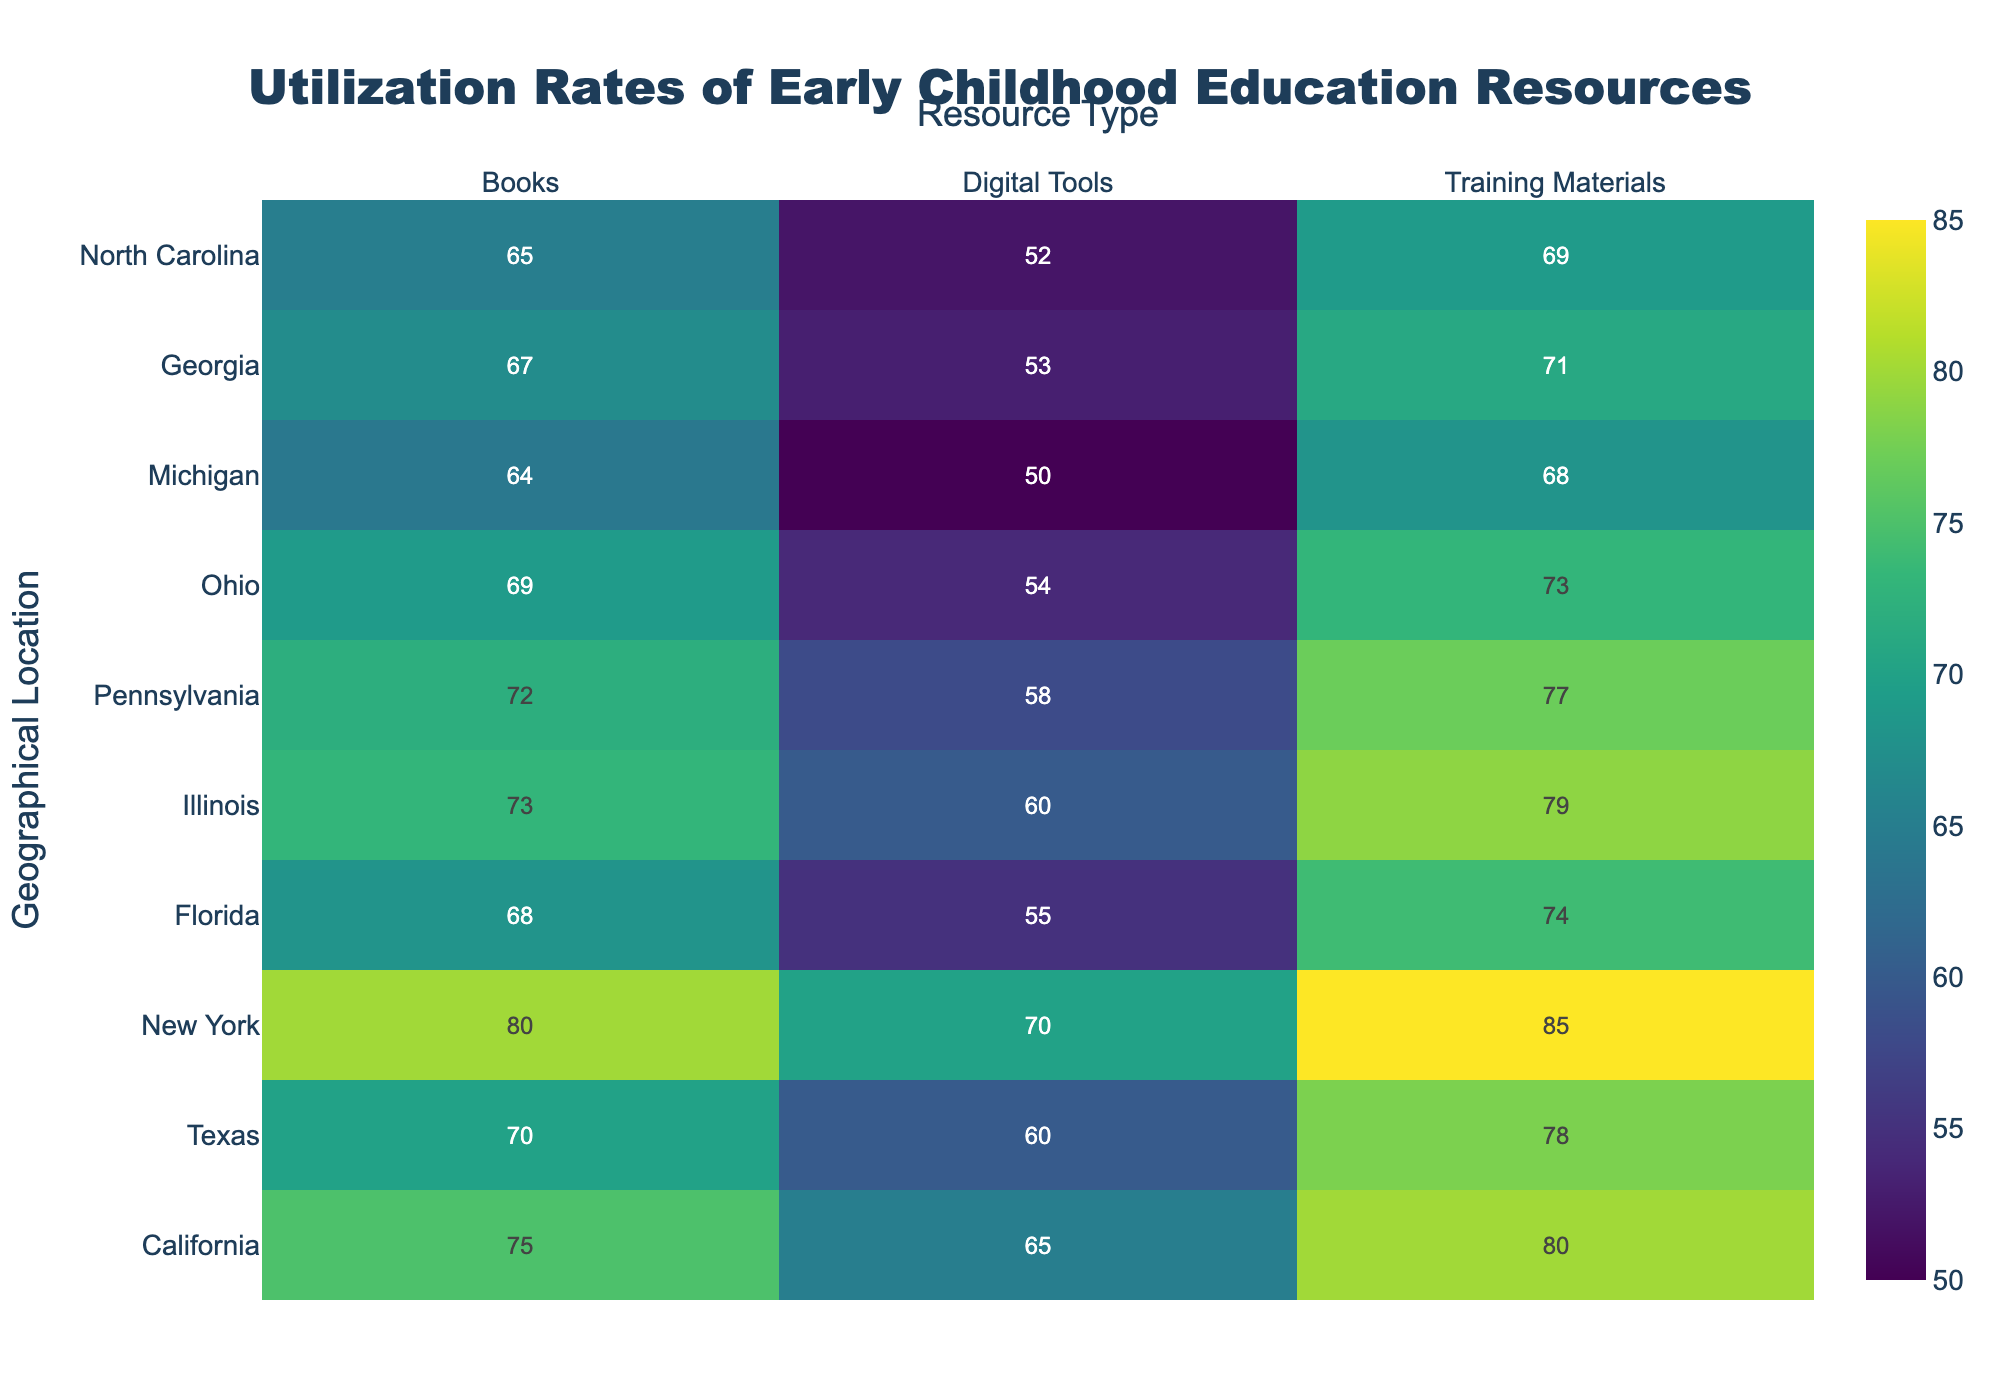What is the title of the heatmap? The title is positioned at the top of the figure. It summarizes the content of the heatmap.
Answer: Utilization Rates of Early Childhood Education Resources Which geographical location has the highest utilization rate for training materials? Look at the column for training materials and identify the highest value. The corresponding geographical location is the answer.
Answer: New York What is the average utilization rate of digital tools across all geographical locations? Add up the utilization rates for digital tools for all locations and then divide by the number of locations (10).
Answer: 57.7 Which resource type shows the highest utilization rate in Texas? Examine the row for Texas, compare the utilization rates for books, digital tools, and training materials. The highest value corresponds to the resource type.
Answer: Training Materials What is the difference in utilization rates for books between New York and Michigan? Subtract the utilization rate of books in Michigan from the utilization rate of books in New York.
Answer: 16 How does the utilization rate for digital tools in California compare to the rate in Florida? Compare the two values directly from the heatmap.
Answer: Higher in California Which geographic location has the lowest utilization rate for digital tools? Find the smallest value in the digital tools column and note the corresponding location.
Answer: Michigan What is the median utilization rate of training materials across all geographical locations? Arrange all utilization rates of training materials in numerical order and find the middle value.
Answer: 75.5 Which resource type in Illinois has nearly the same utilization rate as books in Pennsylvania? Compare the utilization rate of books in Pennsylvania with all resource types in Illinois to find a similar value.
Answer: Digital Tools 